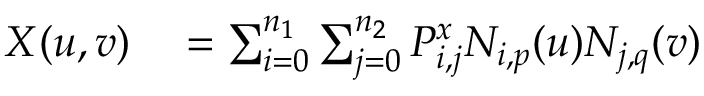Convert formula to latex. <formula><loc_0><loc_0><loc_500><loc_500>\begin{array} { r l } { X ( u , v ) } & = \sum _ { i = 0 } ^ { n _ { 1 } } \sum _ { j = 0 } ^ { n _ { 2 } } P _ { i , j } ^ { x } N _ { i , p } ( u ) N _ { j , q } ( v ) } \end{array}</formula> 